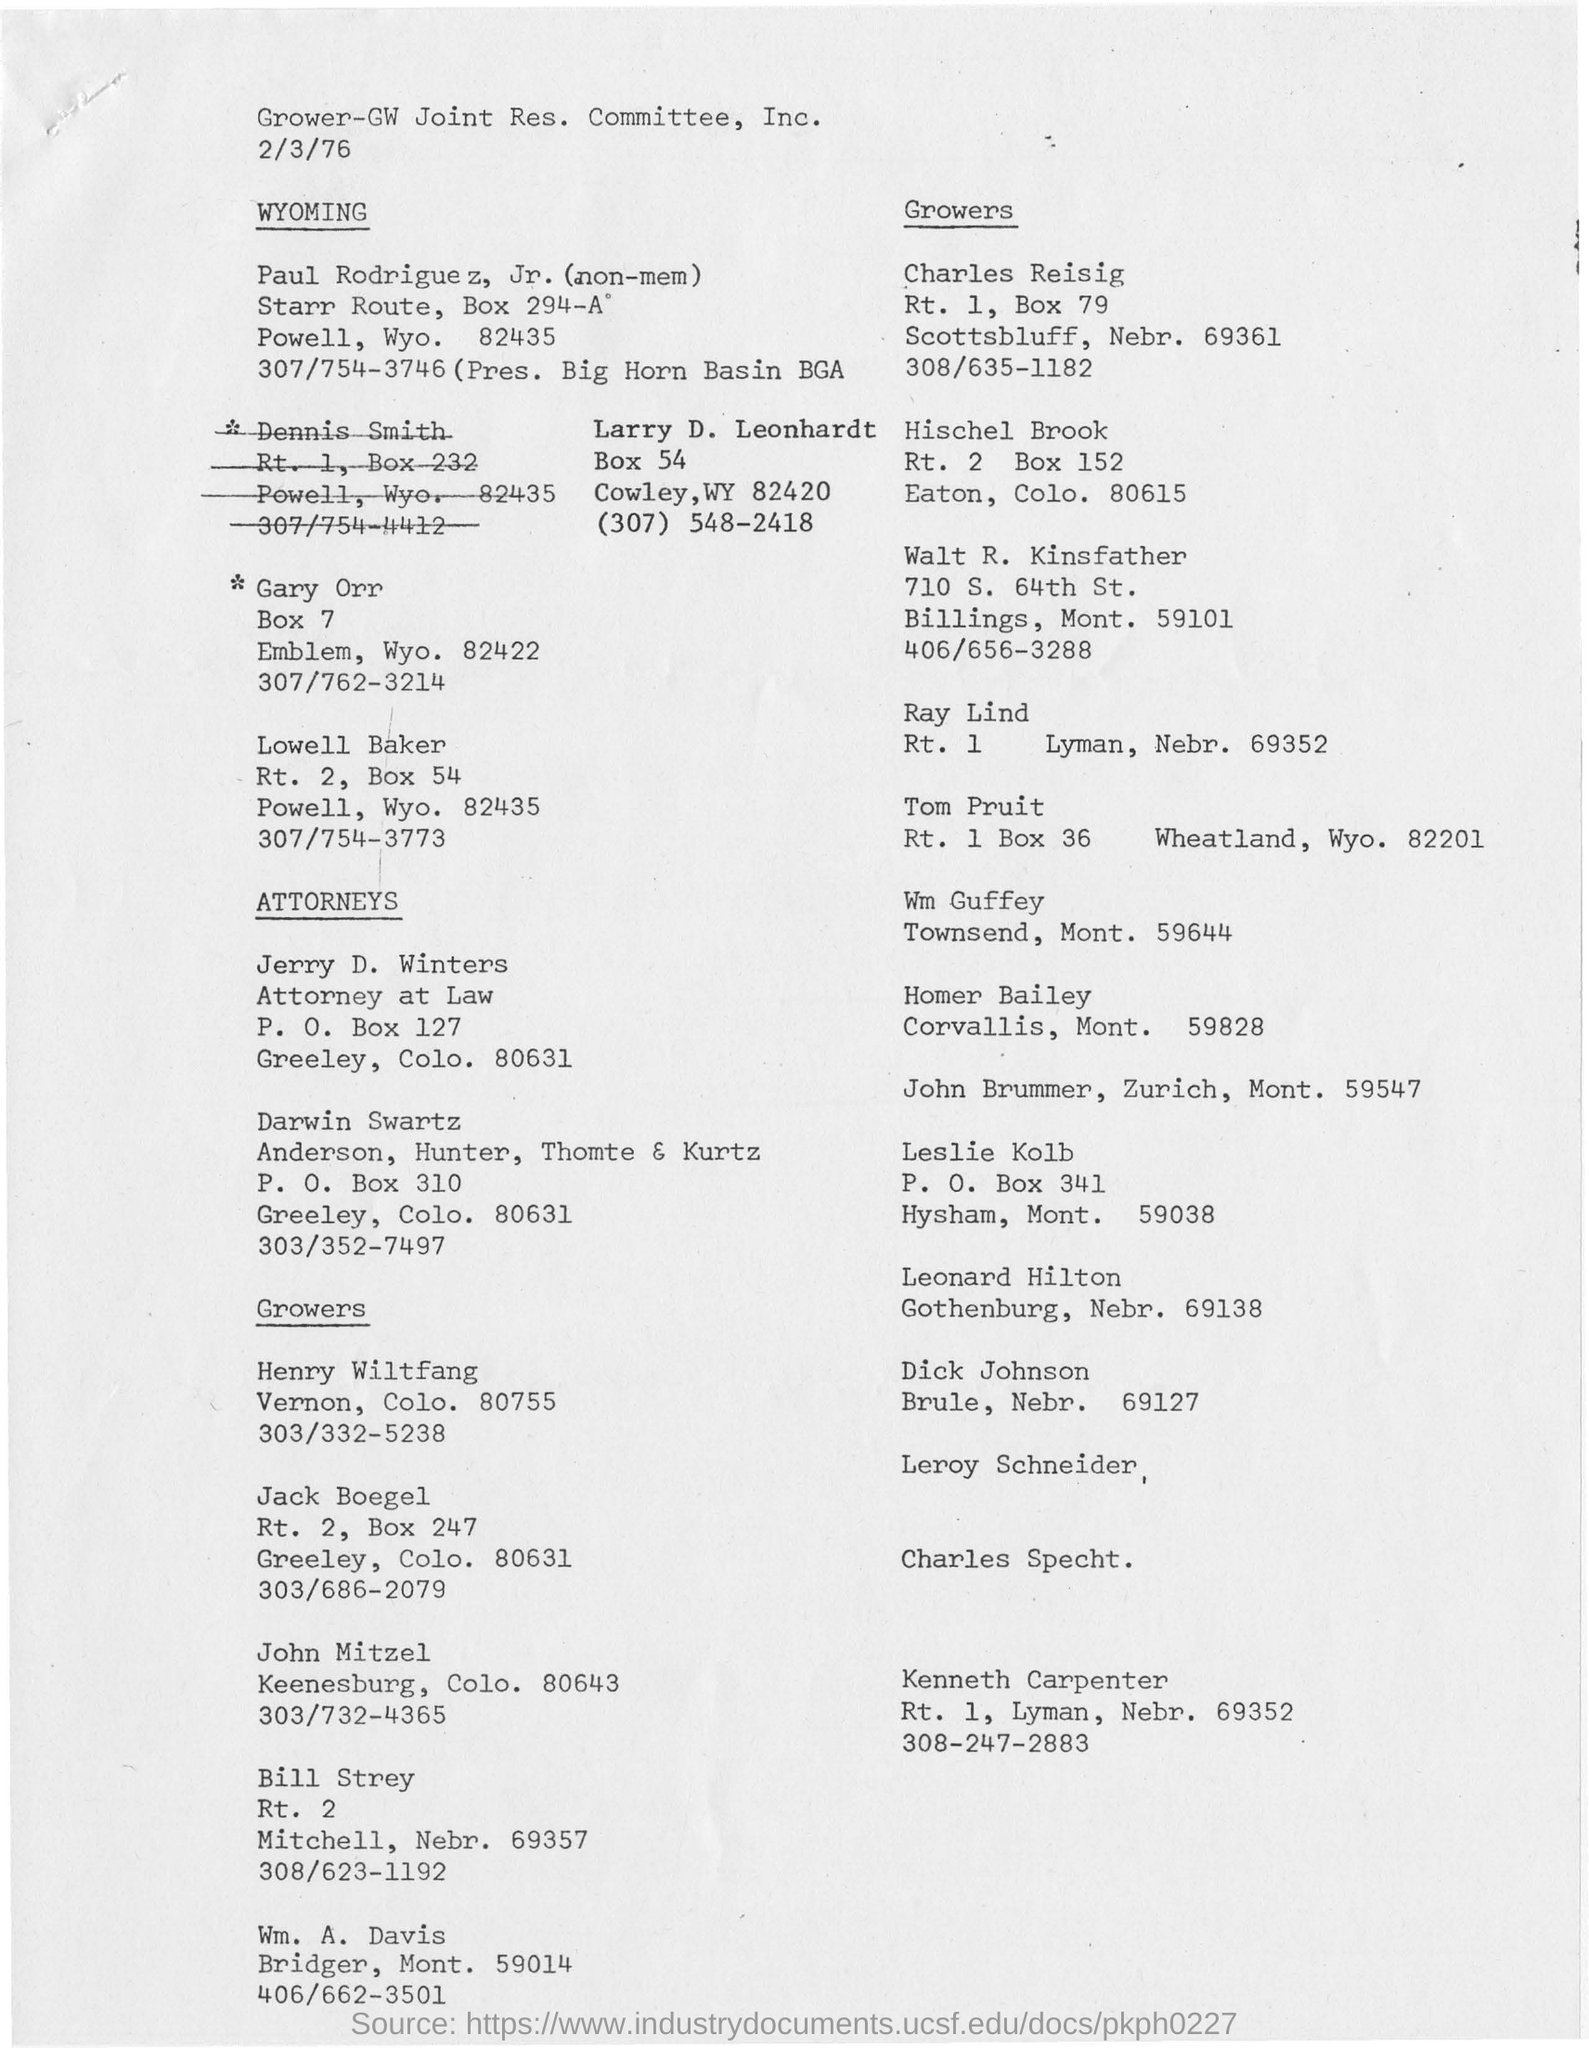What is the name of the committee mentioned ?
Your answer should be compact. Grower-GW Joint Res. Committee, Inc. 